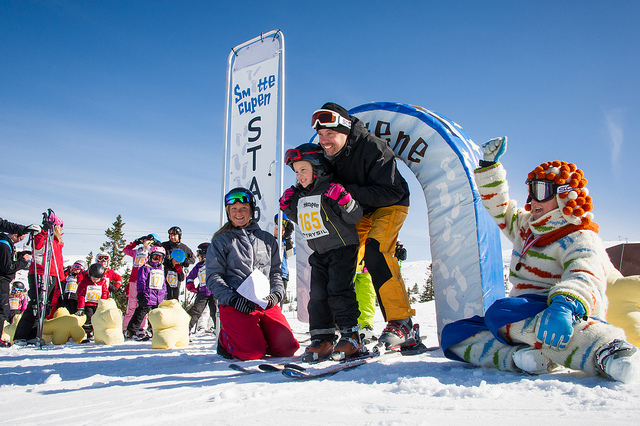Read all the text in this image. STAR SM cupen SM HE one 165 